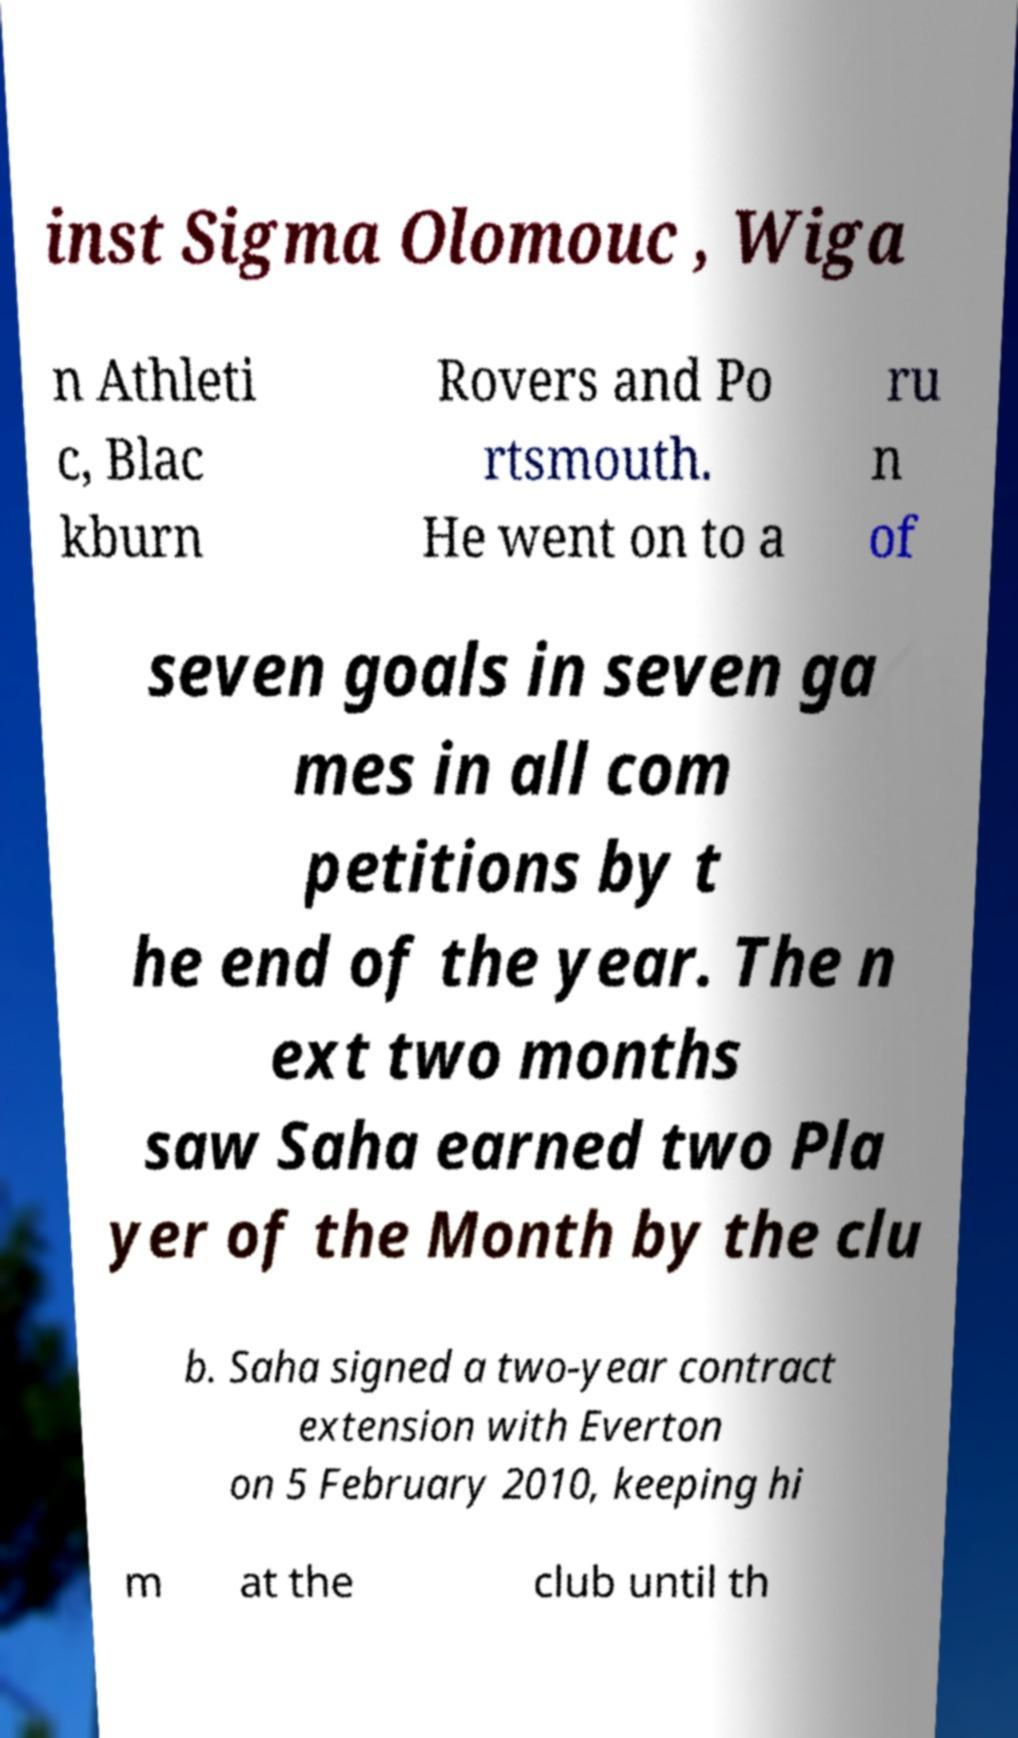I need the written content from this picture converted into text. Can you do that? inst Sigma Olomouc , Wiga n Athleti c, Blac kburn Rovers and Po rtsmouth. He went on to a ru n of seven goals in seven ga mes in all com petitions by t he end of the year. The n ext two months saw Saha earned two Pla yer of the Month by the clu b. Saha signed a two-year contract extension with Everton on 5 February 2010, keeping hi m at the club until th 